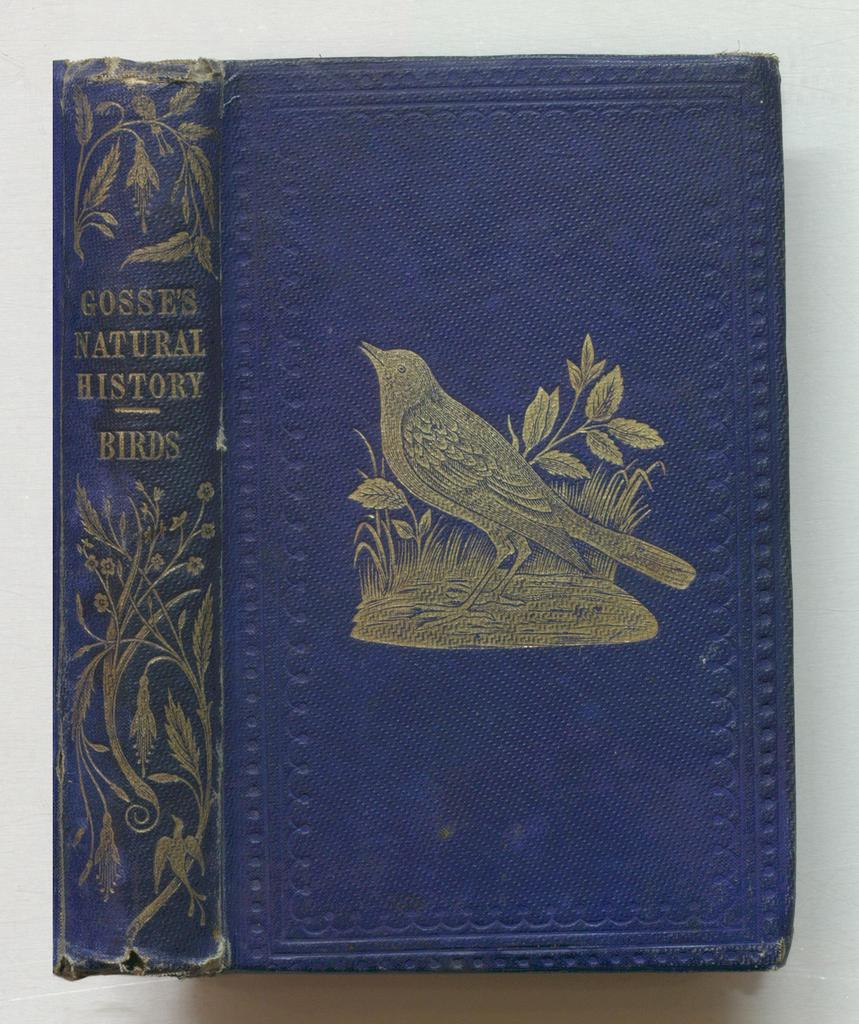<image>
Give a short and clear explanation of the subsequent image. A blue covered book called Gosse's Natural History has a picture of bird on the front of the cover. 